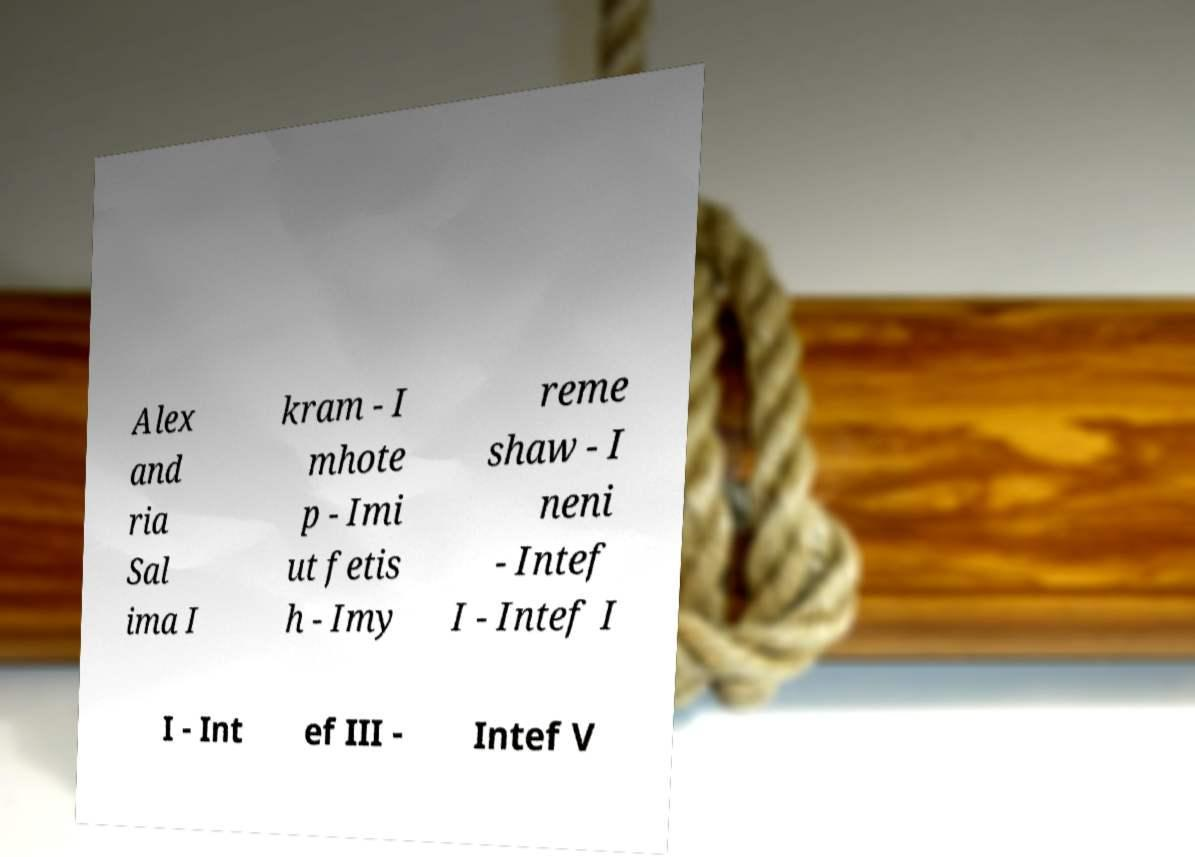Please identify and transcribe the text found in this image. Alex and ria Sal ima I kram - I mhote p - Imi ut fetis h - Imy reme shaw - I neni - Intef I - Intef I I - Int ef III - Intef V 